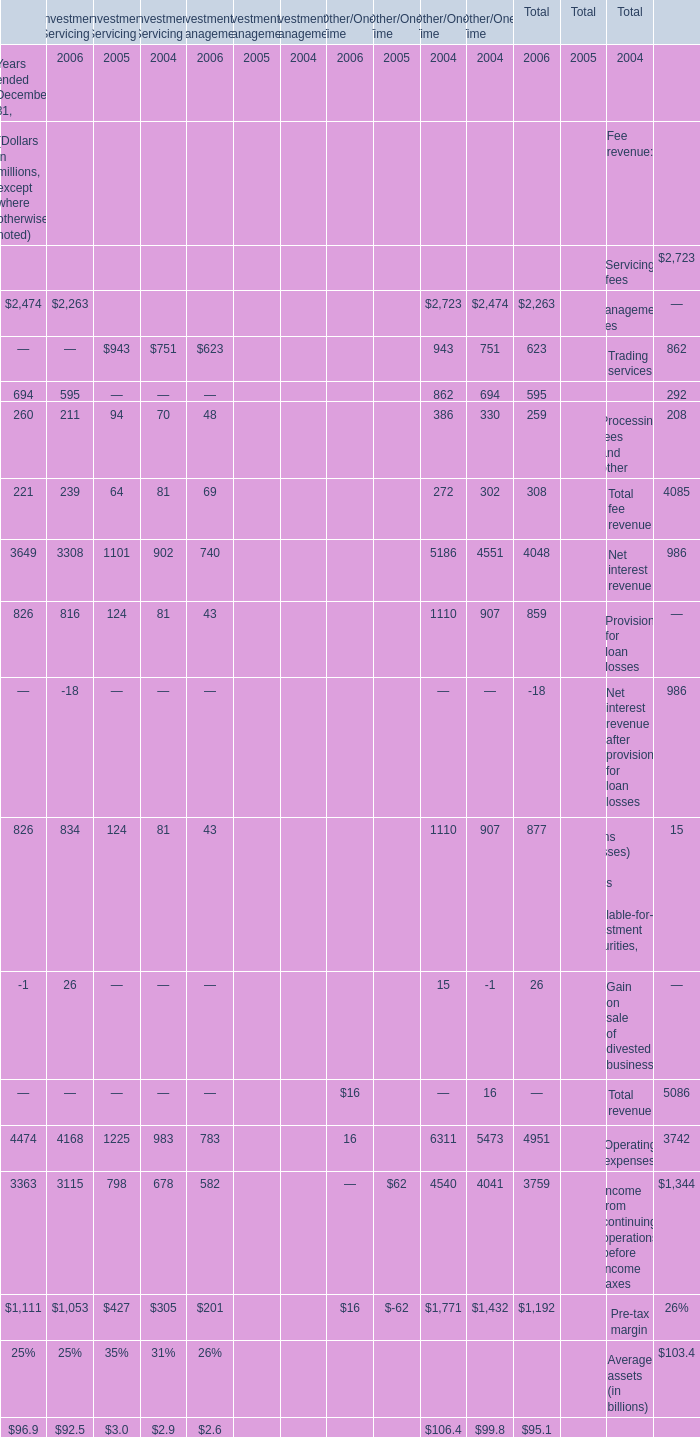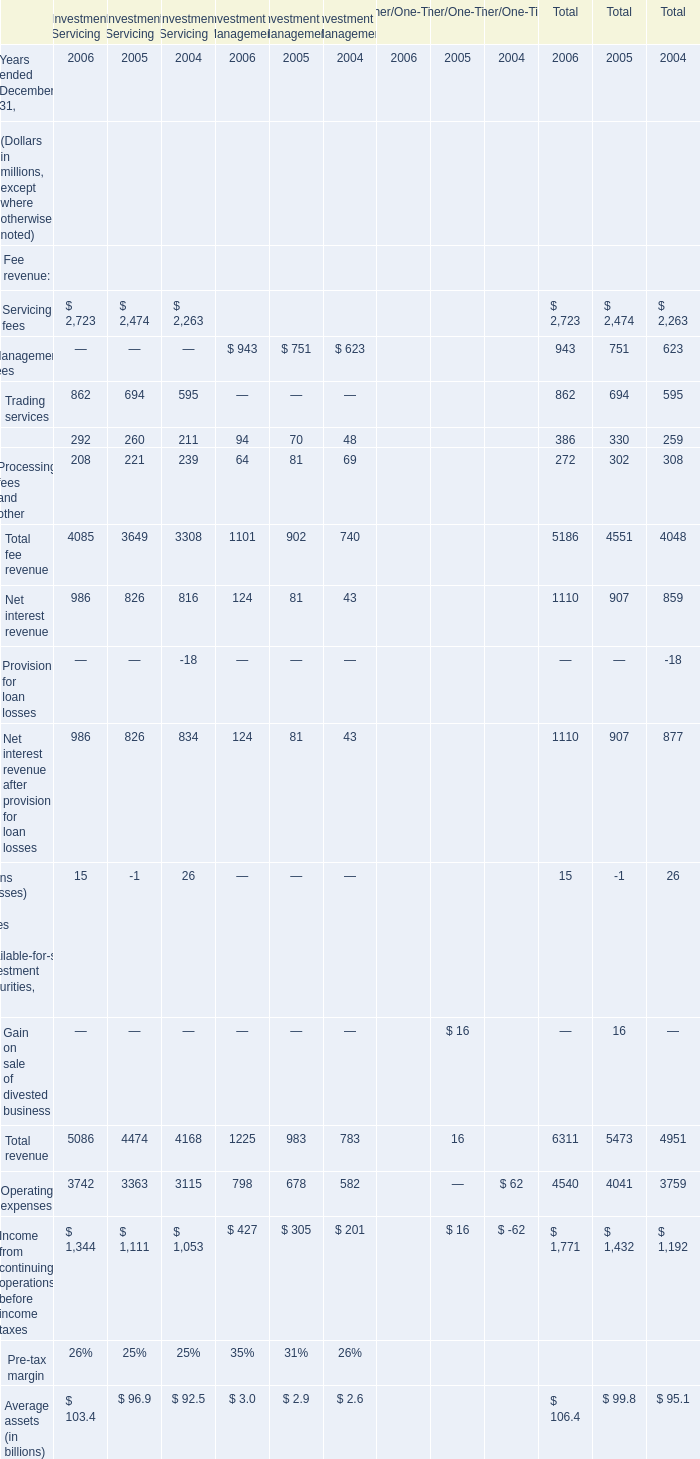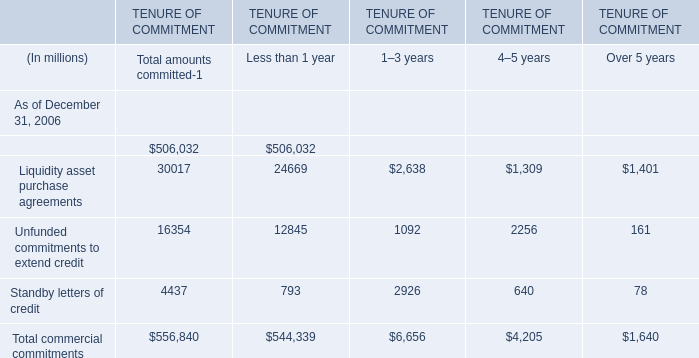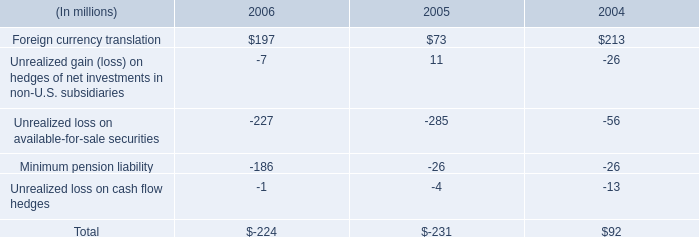in 2006 , what percent of unrealized loss did foreign currency translation offset? 
Computations: (197 / 227)
Answer: 0.86784. 